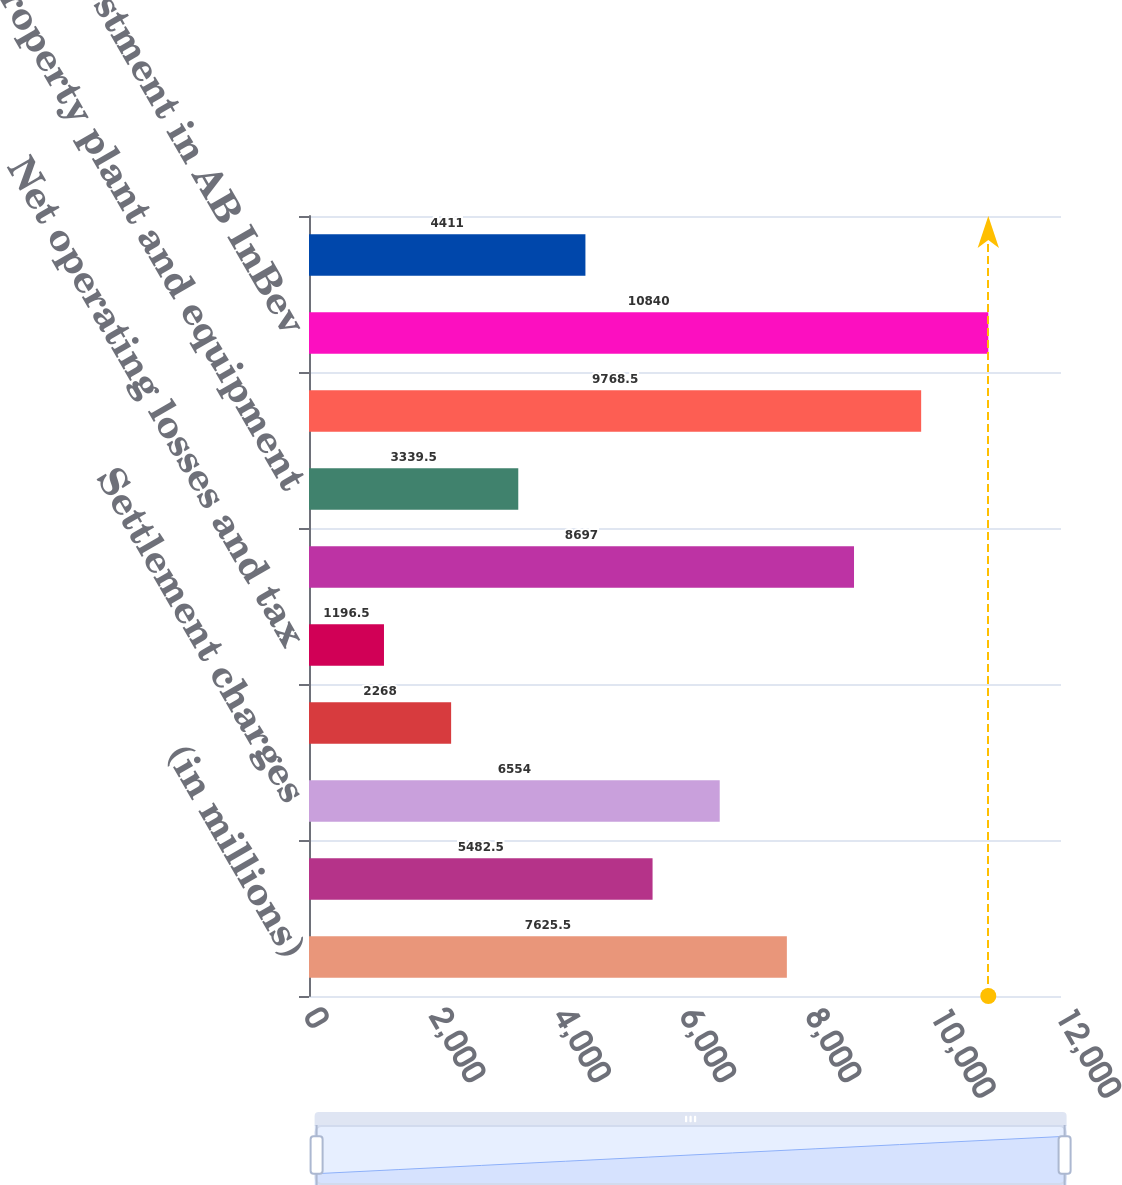Convert chart to OTSL. <chart><loc_0><loc_0><loc_500><loc_500><bar_chart><fcel>(in millions)<fcel>Accrued postretirement and<fcel>Settlement charges<fcel>Accrued pension costs<fcel>Net operating losses and tax<fcel>Total deferred income tax<fcel>Property plant and equipment<fcel>Intangible assets<fcel>Investment in AB InBev<fcel>Finance assets net<nl><fcel>7625.5<fcel>5482.5<fcel>6554<fcel>2268<fcel>1196.5<fcel>8697<fcel>3339.5<fcel>9768.5<fcel>10840<fcel>4411<nl></chart> 